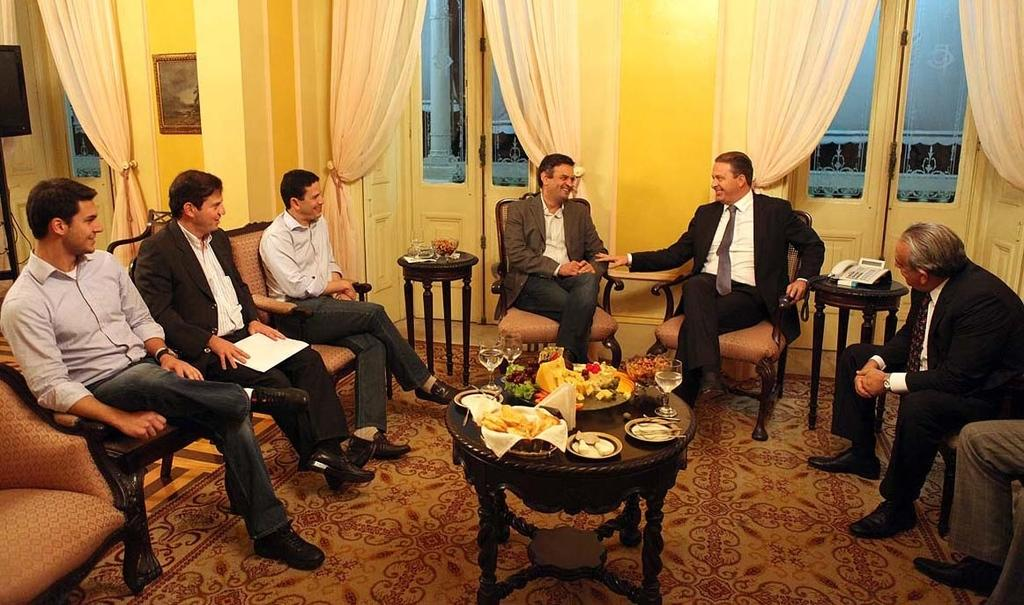What are the people in the image doing? The people in the image are sitting on chairs. What objects are on the table in the image? There are plates, wine glasses, and food items on the table. How many planes can be seen flying in the image? There are no planes visible in the image. Is there a girl sitting on one of the chairs in the image? The provided facts do not mention a girl, so we cannot determine if there is a girl sitting on one of the chairs. 